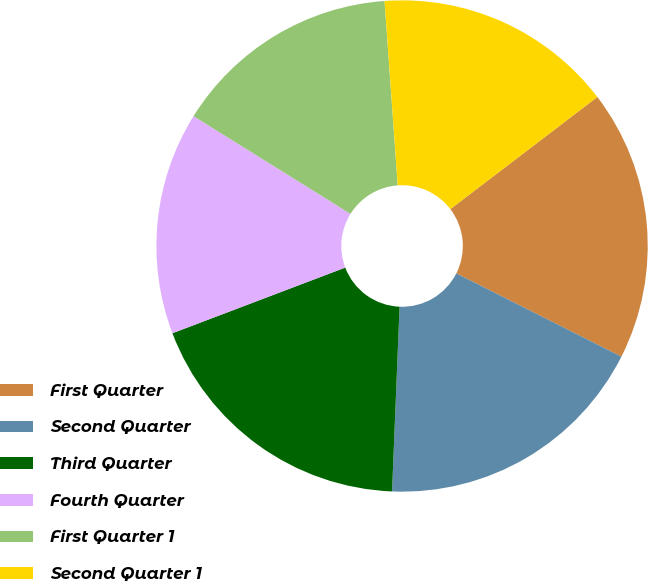<chart> <loc_0><loc_0><loc_500><loc_500><pie_chart><fcel>First Quarter<fcel>Second Quarter<fcel>Third Quarter<fcel>Fourth Quarter<fcel>First Quarter 1<fcel>Second Quarter 1<nl><fcel>17.81%<fcel>18.21%<fcel>18.57%<fcel>14.64%<fcel>15.0%<fcel>15.76%<nl></chart> 